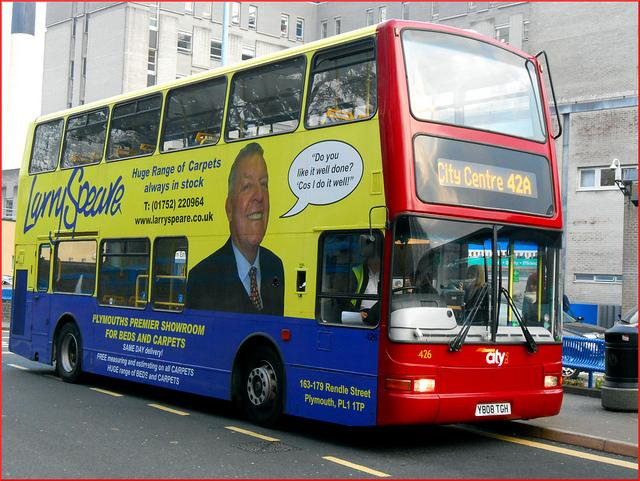What brand of bus manufacturer is displayed on the bus?

Choices:
A) yellowbird
B) grayhound
C) good sam
D) city city 